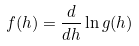<formula> <loc_0><loc_0><loc_500><loc_500>f ( h ) = \frac { d } { d h } \ln g ( h )</formula> 